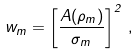Convert formula to latex. <formula><loc_0><loc_0><loc_500><loc_500>w _ { m } = \left [ \frac { A ( \rho _ { m } ) } { \sigma _ { m } } \right ] ^ { 2 } \, ,</formula> 